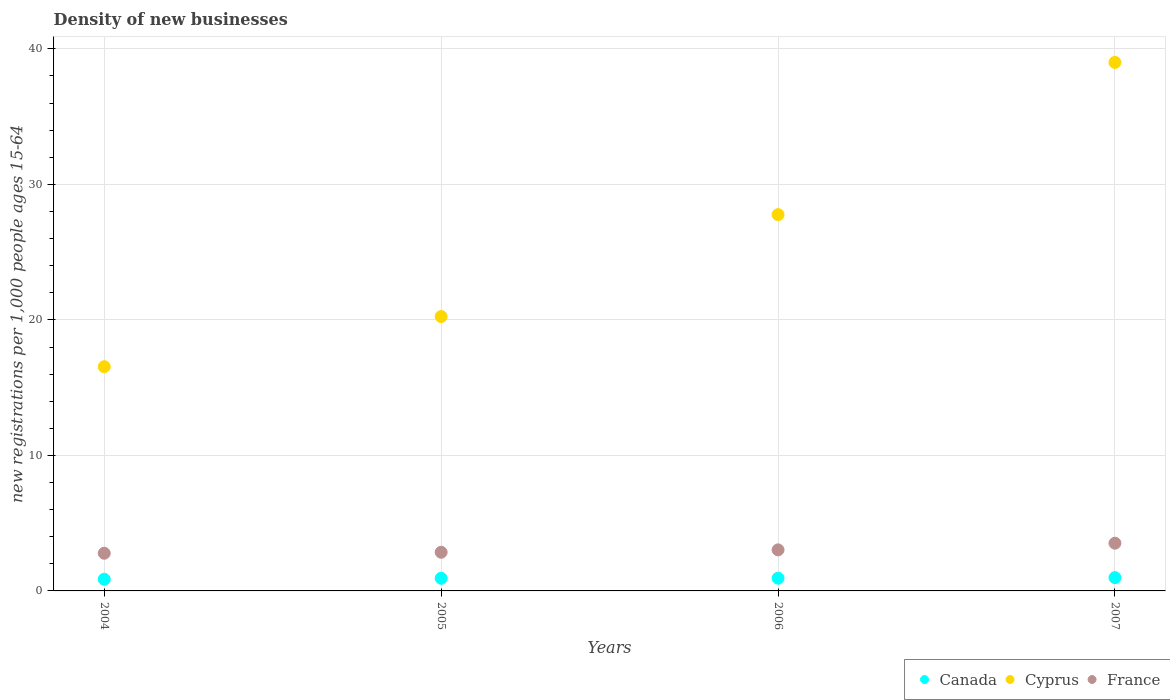Is the number of dotlines equal to the number of legend labels?
Ensure brevity in your answer.  Yes. What is the number of new registrations in Cyprus in 2007?
Provide a short and direct response. 39. Across all years, what is the maximum number of new registrations in Canada?
Keep it short and to the point. 0.98. Across all years, what is the minimum number of new registrations in Canada?
Keep it short and to the point. 0.86. In which year was the number of new registrations in France maximum?
Ensure brevity in your answer.  2007. In which year was the number of new registrations in France minimum?
Your response must be concise. 2004. What is the total number of new registrations in Cyprus in the graph?
Your answer should be very brief. 103.56. What is the difference between the number of new registrations in Cyprus in 2005 and that in 2007?
Your answer should be compact. -18.75. What is the difference between the number of new registrations in France in 2006 and the number of new registrations in Canada in 2004?
Provide a short and direct response. 2.17. What is the average number of new registrations in France per year?
Your answer should be very brief. 3.05. In the year 2006, what is the difference between the number of new registrations in Canada and number of new registrations in Cyprus?
Offer a terse response. -26.83. What is the ratio of the number of new registrations in France in 2005 to that in 2007?
Ensure brevity in your answer.  0.81. What is the difference between the highest and the second highest number of new registrations in Cyprus?
Offer a terse response. 11.23. What is the difference between the highest and the lowest number of new registrations in France?
Your response must be concise. 0.74. In how many years, is the number of new registrations in Canada greater than the average number of new registrations in Canada taken over all years?
Give a very brief answer. 3. Is the sum of the number of new registrations in Cyprus in 2004 and 2007 greater than the maximum number of new registrations in Canada across all years?
Offer a very short reply. Yes. Does the number of new registrations in Canada monotonically increase over the years?
Provide a short and direct response. Yes. Is the number of new registrations in Cyprus strictly greater than the number of new registrations in Canada over the years?
Keep it short and to the point. Yes. Is the number of new registrations in Canada strictly less than the number of new registrations in Cyprus over the years?
Provide a short and direct response. Yes. Does the graph contain any zero values?
Provide a succinct answer. No. What is the title of the graph?
Your answer should be compact. Density of new businesses. Does "Argentina" appear as one of the legend labels in the graph?
Provide a succinct answer. No. What is the label or title of the X-axis?
Provide a succinct answer. Years. What is the label or title of the Y-axis?
Ensure brevity in your answer.  New registrations per 1,0 people ages 15-64. What is the new registrations per 1,000 people ages 15-64 of Canada in 2004?
Ensure brevity in your answer.  0.86. What is the new registrations per 1,000 people ages 15-64 of Cyprus in 2004?
Provide a short and direct response. 16.55. What is the new registrations per 1,000 people ages 15-64 in France in 2004?
Your response must be concise. 2.78. What is the new registrations per 1,000 people ages 15-64 of Canada in 2005?
Ensure brevity in your answer.  0.93. What is the new registrations per 1,000 people ages 15-64 of Cyprus in 2005?
Offer a terse response. 20.25. What is the new registrations per 1,000 people ages 15-64 of France in 2005?
Your response must be concise. 2.85. What is the new registrations per 1,000 people ages 15-64 of Canada in 2006?
Provide a short and direct response. 0.94. What is the new registrations per 1,000 people ages 15-64 in Cyprus in 2006?
Your answer should be very brief. 27.77. What is the new registrations per 1,000 people ages 15-64 in France in 2006?
Your answer should be compact. 3.03. What is the new registrations per 1,000 people ages 15-64 in Canada in 2007?
Offer a terse response. 0.98. What is the new registrations per 1,000 people ages 15-64 of Cyprus in 2007?
Your response must be concise. 39. What is the new registrations per 1,000 people ages 15-64 in France in 2007?
Your answer should be compact. 3.52. Across all years, what is the maximum new registrations per 1,000 people ages 15-64 of Canada?
Your response must be concise. 0.98. Across all years, what is the maximum new registrations per 1,000 people ages 15-64 of Cyprus?
Your answer should be compact. 39. Across all years, what is the maximum new registrations per 1,000 people ages 15-64 in France?
Your answer should be very brief. 3.52. Across all years, what is the minimum new registrations per 1,000 people ages 15-64 in Canada?
Make the answer very short. 0.86. Across all years, what is the minimum new registrations per 1,000 people ages 15-64 of Cyprus?
Provide a short and direct response. 16.55. Across all years, what is the minimum new registrations per 1,000 people ages 15-64 of France?
Your answer should be very brief. 2.78. What is the total new registrations per 1,000 people ages 15-64 of Canada in the graph?
Offer a very short reply. 3.71. What is the total new registrations per 1,000 people ages 15-64 of Cyprus in the graph?
Your answer should be very brief. 103.56. What is the total new registrations per 1,000 people ages 15-64 of France in the graph?
Provide a short and direct response. 12.18. What is the difference between the new registrations per 1,000 people ages 15-64 in Canada in 2004 and that in 2005?
Keep it short and to the point. -0.07. What is the difference between the new registrations per 1,000 people ages 15-64 in Cyprus in 2004 and that in 2005?
Provide a succinct answer. -3.7. What is the difference between the new registrations per 1,000 people ages 15-64 of France in 2004 and that in 2005?
Keep it short and to the point. -0.07. What is the difference between the new registrations per 1,000 people ages 15-64 of Canada in 2004 and that in 2006?
Offer a very short reply. -0.08. What is the difference between the new registrations per 1,000 people ages 15-64 of Cyprus in 2004 and that in 2006?
Your answer should be compact. -11.22. What is the difference between the new registrations per 1,000 people ages 15-64 of France in 2004 and that in 2006?
Your response must be concise. -0.25. What is the difference between the new registrations per 1,000 people ages 15-64 in Canada in 2004 and that in 2007?
Provide a short and direct response. -0.12. What is the difference between the new registrations per 1,000 people ages 15-64 in Cyprus in 2004 and that in 2007?
Offer a very short reply. -22.45. What is the difference between the new registrations per 1,000 people ages 15-64 in France in 2004 and that in 2007?
Ensure brevity in your answer.  -0.74. What is the difference between the new registrations per 1,000 people ages 15-64 in Canada in 2005 and that in 2006?
Provide a succinct answer. -0.01. What is the difference between the new registrations per 1,000 people ages 15-64 in Cyprus in 2005 and that in 2006?
Keep it short and to the point. -7.52. What is the difference between the new registrations per 1,000 people ages 15-64 of France in 2005 and that in 2006?
Offer a terse response. -0.18. What is the difference between the new registrations per 1,000 people ages 15-64 in Canada in 2005 and that in 2007?
Provide a short and direct response. -0.05. What is the difference between the new registrations per 1,000 people ages 15-64 in Cyprus in 2005 and that in 2007?
Your response must be concise. -18.75. What is the difference between the new registrations per 1,000 people ages 15-64 in France in 2005 and that in 2007?
Provide a succinct answer. -0.67. What is the difference between the new registrations per 1,000 people ages 15-64 of Canada in 2006 and that in 2007?
Your answer should be very brief. -0.04. What is the difference between the new registrations per 1,000 people ages 15-64 in Cyprus in 2006 and that in 2007?
Provide a succinct answer. -11.23. What is the difference between the new registrations per 1,000 people ages 15-64 in France in 2006 and that in 2007?
Make the answer very short. -0.49. What is the difference between the new registrations per 1,000 people ages 15-64 of Canada in 2004 and the new registrations per 1,000 people ages 15-64 of Cyprus in 2005?
Make the answer very short. -19.39. What is the difference between the new registrations per 1,000 people ages 15-64 in Canada in 2004 and the new registrations per 1,000 people ages 15-64 in France in 2005?
Provide a succinct answer. -1.99. What is the difference between the new registrations per 1,000 people ages 15-64 in Cyprus in 2004 and the new registrations per 1,000 people ages 15-64 in France in 2005?
Your answer should be very brief. 13.69. What is the difference between the new registrations per 1,000 people ages 15-64 of Canada in 2004 and the new registrations per 1,000 people ages 15-64 of Cyprus in 2006?
Make the answer very short. -26.91. What is the difference between the new registrations per 1,000 people ages 15-64 in Canada in 2004 and the new registrations per 1,000 people ages 15-64 in France in 2006?
Provide a short and direct response. -2.17. What is the difference between the new registrations per 1,000 people ages 15-64 in Cyprus in 2004 and the new registrations per 1,000 people ages 15-64 in France in 2006?
Make the answer very short. 13.52. What is the difference between the new registrations per 1,000 people ages 15-64 of Canada in 2004 and the new registrations per 1,000 people ages 15-64 of Cyprus in 2007?
Keep it short and to the point. -38.14. What is the difference between the new registrations per 1,000 people ages 15-64 of Canada in 2004 and the new registrations per 1,000 people ages 15-64 of France in 2007?
Provide a succinct answer. -2.66. What is the difference between the new registrations per 1,000 people ages 15-64 in Cyprus in 2004 and the new registrations per 1,000 people ages 15-64 in France in 2007?
Offer a terse response. 13.03. What is the difference between the new registrations per 1,000 people ages 15-64 of Canada in 2005 and the new registrations per 1,000 people ages 15-64 of Cyprus in 2006?
Offer a terse response. -26.84. What is the difference between the new registrations per 1,000 people ages 15-64 in Canada in 2005 and the new registrations per 1,000 people ages 15-64 in France in 2006?
Give a very brief answer. -2.1. What is the difference between the new registrations per 1,000 people ages 15-64 of Cyprus in 2005 and the new registrations per 1,000 people ages 15-64 of France in 2006?
Keep it short and to the point. 17.22. What is the difference between the new registrations per 1,000 people ages 15-64 in Canada in 2005 and the new registrations per 1,000 people ages 15-64 in Cyprus in 2007?
Give a very brief answer. -38.07. What is the difference between the new registrations per 1,000 people ages 15-64 of Canada in 2005 and the new registrations per 1,000 people ages 15-64 of France in 2007?
Give a very brief answer. -2.59. What is the difference between the new registrations per 1,000 people ages 15-64 in Cyprus in 2005 and the new registrations per 1,000 people ages 15-64 in France in 2007?
Offer a very short reply. 16.73. What is the difference between the new registrations per 1,000 people ages 15-64 of Canada in 2006 and the new registrations per 1,000 people ages 15-64 of Cyprus in 2007?
Ensure brevity in your answer.  -38.06. What is the difference between the new registrations per 1,000 people ages 15-64 in Canada in 2006 and the new registrations per 1,000 people ages 15-64 in France in 2007?
Offer a very short reply. -2.58. What is the difference between the new registrations per 1,000 people ages 15-64 in Cyprus in 2006 and the new registrations per 1,000 people ages 15-64 in France in 2007?
Make the answer very short. 24.25. What is the average new registrations per 1,000 people ages 15-64 of Cyprus per year?
Provide a succinct answer. 25.89. What is the average new registrations per 1,000 people ages 15-64 of France per year?
Ensure brevity in your answer.  3.05. In the year 2004, what is the difference between the new registrations per 1,000 people ages 15-64 of Canada and new registrations per 1,000 people ages 15-64 of Cyprus?
Ensure brevity in your answer.  -15.68. In the year 2004, what is the difference between the new registrations per 1,000 people ages 15-64 of Canada and new registrations per 1,000 people ages 15-64 of France?
Your answer should be very brief. -1.92. In the year 2004, what is the difference between the new registrations per 1,000 people ages 15-64 of Cyprus and new registrations per 1,000 people ages 15-64 of France?
Your answer should be compact. 13.77. In the year 2005, what is the difference between the new registrations per 1,000 people ages 15-64 in Canada and new registrations per 1,000 people ages 15-64 in Cyprus?
Offer a terse response. -19.32. In the year 2005, what is the difference between the new registrations per 1,000 people ages 15-64 in Canada and new registrations per 1,000 people ages 15-64 in France?
Your response must be concise. -1.92. In the year 2005, what is the difference between the new registrations per 1,000 people ages 15-64 of Cyprus and new registrations per 1,000 people ages 15-64 of France?
Offer a very short reply. 17.39. In the year 2006, what is the difference between the new registrations per 1,000 people ages 15-64 in Canada and new registrations per 1,000 people ages 15-64 in Cyprus?
Make the answer very short. -26.83. In the year 2006, what is the difference between the new registrations per 1,000 people ages 15-64 of Canada and new registrations per 1,000 people ages 15-64 of France?
Your answer should be very brief. -2.09. In the year 2006, what is the difference between the new registrations per 1,000 people ages 15-64 in Cyprus and new registrations per 1,000 people ages 15-64 in France?
Keep it short and to the point. 24.74. In the year 2007, what is the difference between the new registrations per 1,000 people ages 15-64 of Canada and new registrations per 1,000 people ages 15-64 of Cyprus?
Your answer should be compact. -38.02. In the year 2007, what is the difference between the new registrations per 1,000 people ages 15-64 in Canada and new registrations per 1,000 people ages 15-64 in France?
Provide a succinct answer. -2.54. In the year 2007, what is the difference between the new registrations per 1,000 people ages 15-64 of Cyprus and new registrations per 1,000 people ages 15-64 of France?
Provide a short and direct response. 35.48. What is the ratio of the new registrations per 1,000 people ages 15-64 in Canada in 2004 to that in 2005?
Ensure brevity in your answer.  0.92. What is the ratio of the new registrations per 1,000 people ages 15-64 of Cyprus in 2004 to that in 2005?
Ensure brevity in your answer.  0.82. What is the ratio of the new registrations per 1,000 people ages 15-64 in France in 2004 to that in 2005?
Make the answer very short. 0.97. What is the ratio of the new registrations per 1,000 people ages 15-64 of Canada in 2004 to that in 2006?
Give a very brief answer. 0.92. What is the ratio of the new registrations per 1,000 people ages 15-64 of Cyprus in 2004 to that in 2006?
Your response must be concise. 0.6. What is the ratio of the new registrations per 1,000 people ages 15-64 of France in 2004 to that in 2006?
Your response must be concise. 0.92. What is the ratio of the new registrations per 1,000 people ages 15-64 in Canada in 2004 to that in 2007?
Keep it short and to the point. 0.88. What is the ratio of the new registrations per 1,000 people ages 15-64 in Cyprus in 2004 to that in 2007?
Your answer should be very brief. 0.42. What is the ratio of the new registrations per 1,000 people ages 15-64 of France in 2004 to that in 2007?
Make the answer very short. 0.79. What is the ratio of the new registrations per 1,000 people ages 15-64 in Cyprus in 2005 to that in 2006?
Offer a very short reply. 0.73. What is the ratio of the new registrations per 1,000 people ages 15-64 in France in 2005 to that in 2006?
Ensure brevity in your answer.  0.94. What is the ratio of the new registrations per 1,000 people ages 15-64 in Canada in 2005 to that in 2007?
Make the answer very short. 0.95. What is the ratio of the new registrations per 1,000 people ages 15-64 in Cyprus in 2005 to that in 2007?
Offer a terse response. 0.52. What is the ratio of the new registrations per 1,000 people ages 15-64 in France in 2005 to that in 2007?
Offer a very short reply. 0.81. What is the ratio of the new registrations per 1,000 people ages 15-64 in Canada in 2006 to that in 2007?
Provide a succinct answer. 0.96. What is the ratio of the new registrations per 1,000 people ages 15-64 in Cyprus in 2006 to that in 2007?
Provide a succinct answer. 0.71. What is the ratio of the new registrations per 1,000 people ages 15-64 of France in 2006 to that in 2007?
Your response must be concise. 0.86. What is the difference between the highest and the second highest new registrations per 1,000 people ages 15-64 in Canada?
Your answer should be very brief. 0.04. What is the difference between the highest and the second highest new registrations per 1,000 people ages 15-64 of Cyprus?
Offer a terse response. 11.23. What is the difference between the highest and the second highest new registrations per 1,000 people ages 15-64 of France?
Provide a short and direct response. 0.49. What is the difference between the highest and the lowest new registrations per 1,000 people ages 15-64 of Canada?
Your answer should be very brief. 0.12. What is the difference between the highest and the lowest new registrations per 1,000 people ages 15-64 in Cyprus?
Give a very brief answer. 22.45. What is the difference between the highest and the lowest new registrations per 1,000 people ages 15-64 of France?
Give a very brief answer. 0.74. 